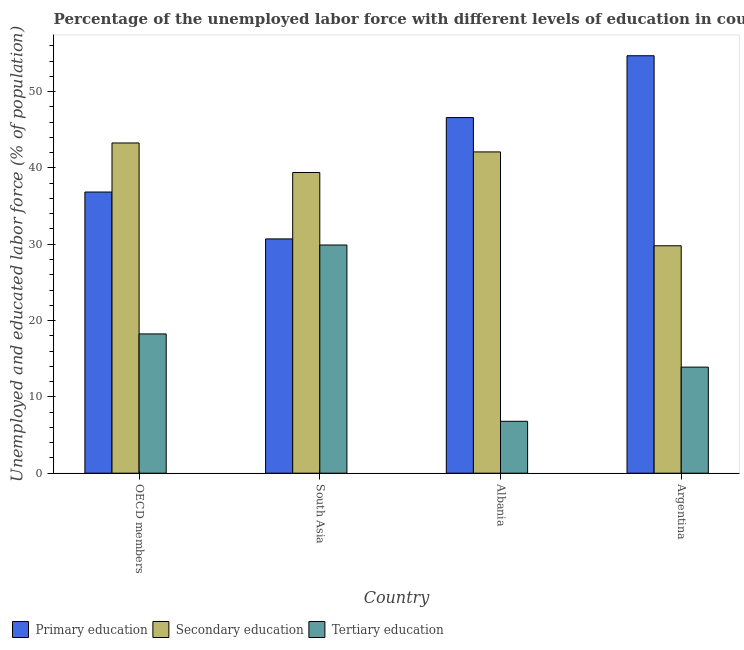How many different coloured bars are there?
Make the answer very short. 3. How many groups of bars are there?
Provide a succinct answer. 4. Are the number of bars per tick equal to the number of legend labels?
Make the answer very short. Yes. How many bars are there on the 1st tick from the left?
Ensure brevity in your answer.  3. How many bars are there on the 3rd tick from the right?
Offer a very short reply. 3. What is the label of the 1st group of bars from the left?
Keep it short and to the point. OECD members. In how many cases, is the number of bars for a given country not equal to the number of legend labels?
Your answer should be compact. 0. What is the percentage of labor force who received secondary education in Argentina?
Provide a short and direct response. 29.8. Across all countries, what is the maximum percentage of labor force who received secondary education?
Ensure brevity in your answer.  43.27. Across all countries, what is the minimum percentage of labor force who received primary education?
Provide a short and direct response. 30.7. In which country was the percentage of labor force who received secondary education maximum?
Your answer should be compact. OECD members. In which country was the percentage of labor force who received tertiary education minimum?
Your answer should be compact. Albania. What is the total percentage of labor force who received primary education in the graph?
Provide a short and direct response. 168.84. What is the difference between the percentage of labor force who received secondary education in Argentina and that in OECD members?
Offer a very short reply. -13.47. What is the difference between the percentage of labor force who received secondary education in OECD members and the percentage of labor force who received tertiary education in Albania?
Your answer should be compact. 36.47. What is the average percentage of labor force who received primary education per country?
Your answer should be very brief. 42.21. What is the difference between the percentage of labor force who received primary education and percentage of labor force who received secondary education in OECD members?
Your answer should be compact. -6.43. What is the ratio of the percentage of labor force who received primary education in OECD members to that in South Asia?
Your answer should be very brief. 1.2. What is the difference between the highest and the second highest percentage of labor force who received secondary education?
Offer a terse response. 1.17. What is the difference between the highest and the lowest percentage of labor force who received primary education?
Offer a very short reply. 24. What does the 1st bar from the left in Albania represents?
Give a very brief answer. Primary education. What does the 3rd bar from the right in OECD members represents?
Give a very brief answer. Primary education. Is it the case that in every country, the sum of the percentage of labor force who received primary education and percentage of labor force who received secondary education is greater than the percentage of labor force who received tertiary education?
Keep it short and to the point. Yes. Are all the bars in the graph horizontal?
Keep it short and to the point. No. Does the graph contain any zero values?
Provide a succinct answer. No. Where does the legend appear in the graph?
Your answer should be very brief. Bottom left. How many legend labels are there?
Ensure brevity in your answer.  3. What is the title of the graph?
Offer a terse response. Percentage of the unemployed labor force with different levels of education in countries. What is the label or title of the Y-axis?
Your answer should be very brief. Unemployed and educated labor force (% of population). What is the Unemployed and educated labor force (% of population) in Primary education in OECD members?
Your answer should be compact. 36.84. What is the Unemployed and educated labor force (% of population) in Secondary education in OECD members?
Offer a terse response. 43.27. What is the Unemployed and educated labor force (% of population) in Tertiary education in OECD members?
Make the answer very short. 18.25. What is the Unemployed and educated labor force (% of population) of Primary education in South Asia?
Offer a terse response. 30.7. What is the Unemployed and educated labor force (% of population) in Secondary education in South Asia?
Offer a very short reply. 39.4. What is the Unemployed and educated labor force (% of population) of Tertiary education in South Asia?
Make the answer very short. 29.9. What is the Unemployed and educated labor force (% of population) in Primary education in Albania?
Give a very brief answer. 46.6. What is the Unemployed and educated labor force (% of population) in Secondary education in Albania?
Your response must be concise. 42.1. What is the Unemployed and educated labor force (% of population) of Tertiary education in Albania?
Provide a short and direct response. 6.8. What is the Unemployed and educated labor force (% of population) of Primary education in Argentina?
Ensure brevity in your answer.  54.7. What is the Unemployed and educated labor force (% of population) of Secondary education in Argentina?
Provide a short and direct response. 29.8. What is the Unemployed and educated labor force (% of population) in Tertiary education in Argentina?
Offer a very short reply. 13.9. Across all countries, what is the maximum Unemployed and educated labor force (% of population) of Primary education?
Provide a succinct answer. 54.7. Across all countries, what is the maximum Unemployed and educated labor force (% of population) of Secondary education?
Provide a succinct answer. 43.27. Across all countries, what is the maximum Unemployed and educated labor force (% of population) of Tertiary education?
Provide a short and direct response. 29.9. Across all countries, what is the minimum Unemployed and educated labor force (% of population) of Primary education?
Your response must be concise. 30.7. Across all countries, what is the minimum Unemployed and educated labor force (% of population) of Secondary education?
Your answer should be very brief. 29.8. Across all countries, what is the minimum Unemployed and educated labor force (% of population) of Tertiary education?
Keep it short and to the point. 6.8. What is the total Unemployed and educated labor force (% of population) in Primary education in the graph?
Offer a terse response. 168.84. What is the total Unemployed and educated labor force (% of population) of Secondary education in the graph?
Provide a succinct answer. 154.57. What is the total Unemployed and educated labor force (% of population) in Tertiary education in the graph?
Your answer should be compact. 68.85. What is the difference between the Unemployed and educated labor force (% of population) of Primary education in OECD members and that in South Asia?
Your answer should be very brief. 6.14. What is the difference between the Unemployed and educated labor force (% of population) of Secondary education in OECD members and that in South Asia?
Offer a terse response. 3.87. What is the difference between the Unemployed and educated labor force (% of population) in Tertiary education in OECD members and that in South Asia?
Give a very brief answer. -11.65. What is the difference between the Unemployed and educated labor force (% of population) in Primary education in OECD members and that in Albania?
Offer a very short reply. -9.76. What is the difference between the Unemployed and educated labor force (% of population) in Secondary education in OECD members and that in Albania?
Provide a succinct answer. 1.17. What is the difference between the Unemployed and educated labor force (% of population) of Tertiary education in OECD members and that in Albania?
Provide a short and direct response. 11.45. What is the difference between the Unemployed and educated labor force (% of population) in Primary education in OECD members and that in Argentina?
Your answer should be very brief. -17.86. What is the difference between the Unemployed and educated labor force (% of population) in Secondary education in OECD members and that in Argentina?
Provide a succinct answer. 13.47. What is the difference between the Unemployed and educated labor force (% of population) in Tertiary education in OECD members and that in Argentina?
Your answer should be very brief. 4.35. What is the difference between the Unemployed and educated labor force (% of population) of Primary education in South Asia and that in Albania?
Your answer should be very brief. -15.9. What is the difference between the Unemployed and educated labor force (% of population) of Secondary education in South Asia and that in Albania?
Provide a succinct answer. -2.7. What is the difference between the Unemployed and educated labor force (% of population) in Tertiary education in South Asia and that in Albania?
Your answer should be very brief. 23.1. What is the difference between the Unemployed and educated labor force (% of population) of Primary education in Albania and that in Argentina?
Provide a short and direct response. -8.1. What is the difference between the Unemployed and educated labor force (% of population) of Tertiary education in Albania and that in Argentina?
Your answer should be compact. -7.1. What is the difference between the Unemployed and educated labor force (% of population) in Primary education in OECD members and the Unemployed and educated labor force (% of population) in Secondary education in South Asia?
Your answer should be very brief. -2.56. What is the difference between the Unemployed and educated labor force (% of population) of Primary education in OECD members and the Unemployed and educated labor force (% of population) of Tertiary education in South Asia?
Give a very brief answer. 6.94. What is the difference between the Unemployed and educated labor force (% of population) in Secondary education in OECD members and the Unemployed and educated labor force (% of population) in Tertiary education in South Asia?
Your answer should be compact. 13.37. What is the difference between the Unemployed and educated labor force (% of population) of Primary education in OECD members and the Unemployed and educated labor force (% of population) of Secondary education in Albania?
Provide a succinct answer. -5.26. What is the difference between the Unemployed and educated labor force (% of population) of Primary education in OECD members and the Unemployed and educated labor force (% of population) of Tertiary education in Albania?
Offer a terse response. 30.04. What is the difference between the Unemployed and educated labor force (% of population) in Secondary education in OECD members and the Unemployed and educated labor force (% of population) in Tertiary education in Albania?
Offer a very short reply. 36.47. What is the difference between the Unemployed and educated labor force (% of population) in Primary education in OECD members and the Unemployed and educated labor force (% of population) in Secondary education in Argentina?
Keep it short and to the point. 7.04. What is the difference between the Unemployed and educated labor force (% of population) of Primary education in OECD members and the Unemployed and educated labor force (% of population) of Tertiary education in Argentina?
Keep it short and to the point. 22.94. What is the difference between the Unemployed and educated labor force (% of population) in Secondary education in OECD members and the Unemployed and educated labor force (% of population) in Tertiary education in Argentina?
Ensure brevity in your answer.  29.37. What is the difference between the Unemployed and educated labor force (% of population) of Primary education in South Asia and the Unemployed and educated labor force (% of population) of Secondary education in Albania?
Offer a very short reply. -11.4. What is the difference between the Unemployed and educated labor force (% of population) in Primary education in South Asia and the Unemployed and educated labor force (% of population) in Tertiary education in Albania?
Your answer should be very brief. 23.9. What is the difference between the Unemployed and educated labor force (% of population) in Secondary education in South Asia and the Unemployed and educated labor force (% of population) in Tertiary education in Albania?
Your response must be concise. 32.6. What is the difference between the Unemployed and educated labor force (% of population) of Primary education in Albania and the Unemployed and educated labor force (% of population) of Secondary education in Argentina?
Keep it short and to the point. 16.8. What is the difference between the Unemployed and educated labor force (% of population) in Primary education in Albania and the Unemployed and educated labor force (% of population) in Tertiary education in Argentina?
Make the answer very short. 32.7. What is the difference between the Unemployed and educated labor force (% of population) in Secondary education in Albania and the Unemployed and educated labor force (% of population) in Tertiary education in Argentina?
Ensure brevity in your answer.  28.2. What is the average Unemployed and educated labor force (% of population) in Primary education per country?
Keep it short and to the point. 42.21. What is the average Unemployed and educated labor force (% of population) in Secondary education per country?
Provide a succinct answer. 38.64. What is the average Unemployed and educated labor force (% of population) of Tertiary education per country?
Offer a terse response. 17.21. What is the difference between the Unemployed and educated labor force (% of population) of Primary education and Unemployed and educated labor force (% of population) of Secondary education in OECD members?
Give a very brief answer. -6.43. What is the difference between the Unemployed and educated labor force (% of population) of Primary education and Unemployed and educated labor force (% of population) of Tertiary education in OECD members?
Keep it short and to the point. 18.6. What is the difference between the Unemployed and educated labor force (% of population) in Secondary education and Unemployed and educated labor force (% of population) in Tertiary education in OECD members?
Ensure brevity in your answer.  25.02. What is the difference between the Unemployed and educated labor force (% of population) in Secondary education and Unemployed and educated labor force (% of population) in Tertiary education in South Asia?
Ensure brevity in your answer.  9.5. What is the difference between the Unemployed and educated labor force (% of population) of Primary education and Unemployed and educated labor force (% of population) of Secondary education in Albania?
Provide a succinct answer. 4.5. What is the difference between the Unemployed and educated labor force (% of population) in Primary education and Unemployed and educated labor force (% of population) in Tertiary education in Albania?
Provide a short and direct response. 39.8. What is the difference between the Unemployed and educated labor force (% of population) of Secondary education and Unemployed and educated labor force (% of population) of Tertiary education in Albania?
Give a very brief answer. 35.3. What is the difference between the Unemployed and educated labor force (% of population) in Primary education and Unemployed and educated labor force (% of population) in Secondary education in Argentina?
Your answer should be very brief. 24.9. What is the difference between the Unemployed and educated labor force (% of population) of Primary education and Unemployed and educated labor force (% of population) of Tertiary education in Argentina?
Your answer should be compact. 40.8. What is the difference between the Unemployed and educated labor force (% of population) of Secondary education and Unemployed and educated labor force (% of population) of Tertiary education in Argentina?
Ensure brevity in your answer.  15.9. What is the ratio of the Unemployed and educated labor force (% of population) in Primary education in OECD members to that in South Asia?
Provide a succinct answer. 1.2. What is the ratio of the Unemployed and educated labor force (% of population) of Secondary education in OECD members to that in South Asia?
Give a very brief answer. 1.1. What is the ratio of the Unemployed and educated labor force (% of population) in Tertiary education in OECD members to that in South Asia?
Your response must be concise. 0.61. What is the ratio of the Unemployed and educated labor force (% of population) in Primary education in OECD members to that in Albania?
Keep it short and to the point. 0.79. What is the ratio of the Unemployed and educated labor force (% of population) in Secondary education in OECD members to that in Albania?
Ensure brevity in your answer.  1.03. What is the ratio of the Unemployed and educated labor force (% of population) of Tertiary education in OECD members to that in Albania?
Ensure brevity in your answer.  2.68. What is the ratio of the Unemployed and educated labor force (% of population) of Primary education in OECD members to that in Argentina?
Provide a short and direct response. 0.67. What is the ratio of the Unemployed and educated labor force (% of population) of Secondary education in OECD members to that in Argentina?
Provide a succinct answer. 1.45. What is the ratio of the Unemployed and educated labor force (% of population) in Tertiary education in OECD members to that in Argentina?
Provide a short and direct response. 1.31. What is the ratio of the Unemployed and educated labor force (% of population) of Primary education in South Asia to that in Albania?
Give a very brief answer. 0.66. What is the ratio of the Unemployed and educated labor force (% of population) in Secondary education in South Asia to that in Albania?
Offer a terse response. 0.94. What is the ratio of the Unemployed and educated labor force (% of population) in Tertiary education in South Asia to that in Albania?
Ensure brevity in your answer.  4.4. What is the ratio of the Unemployed and educated labor force (% of population) in Primary education in South Asia to that in Argentina?
Your answer should be compact. 0.56. What is the ratio of the Unemployed and educated labor force (% of population) of Secondary education in South Asia to that in Argentina?
Give a very brief answer. 1.32. What is the ratio of the Unemployed and educated labor force (% of population) of Tertiary education in South Asia to that in Argentina?
Provide a succinct answer. 2.15. What is the ratio of the Unemployed and educated labor force (% of population) in Primary education in Albania to that in Argentina?
Make the answer very short. 0.85. What is the ratio of the Unemployed and educated labor force (% of population) of Secondary education in Albania to that in Argentina?
Ensure brevity in your answer.  1.41. What is the ratio of the Unemployed and educated labor force (% of population) of Tertiary education in Albania to that in Argentina?
Make the answer very short. 0.49. What is the difference between the highest and the second highest Unemployed and educated labor force (% of population) of Secondary education?
Offer a very short reply. 1.17. What is the difference between the highest and the second highest Unemployed and educated labor force (% of population) of Tertiary education?
Provide a succinct answer. 11.65. What is the difference between the highest and the lowest Unemployed and educated labor force (% of population) of Primary education?
Your answer should be very brief. 24. What is the difference between the highest and the lowest Unemployed and educated labor force (% of population) of Secondary education?
Ensure brevity in your answer.  13.47. What is the difference between the highest and the lowest Unemployed and educated labor force (% of population) in Tertiary education?
Make the answer very short. 23.1. 